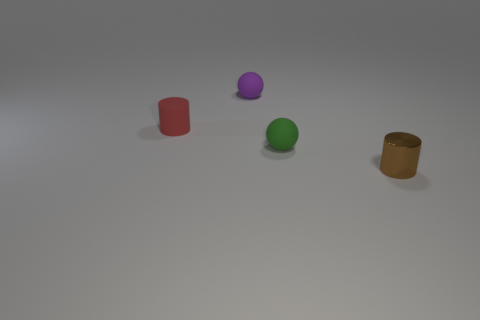What is the ball that is in front of the matte ball behind the tiny cylinder behind the small green matte thing made of? The ball in question appears to be made of a plastic material, as it has a glossy finish which is common with plastic objects. Its shine and reflection are consistent with those of synthetic polymers rather than natural rubber. 